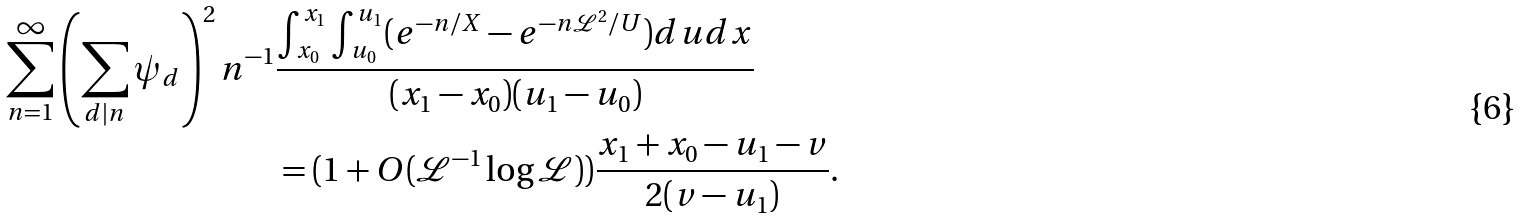Convert formula to latex. <formula><loc_0><loc_0><loc_500><loc_500>\sum _ { n = 1 } ^ { \infty } \left ( \sum _ { d | n } \psi _ { d } \right ) ^ { 2 } n ^ { - 1 } & \frac { \int _ { x _ { 0 } } ^ { x _ { 1 } } \int _ { u _ { 0 } } ^ { u _ { 1 } } ( e ^ { - n / X } - e ^ { - n \mathcal { L } ^ { 2 } / U } ) d u d x } { ( x _ { 1 } - x _ { 0 } ) ( u _ { 1 } - u _ { 0 } ) } \\ & = ( 1 + O ( \mathcal { L } ^ { - 1 } \log { \mathcal { L } } ) ) \frac { x _ { 1 } + x _ { 0 } - u _ { 1 } - v } { 2 ( v - u _ { 1 } ) } .</formula> 